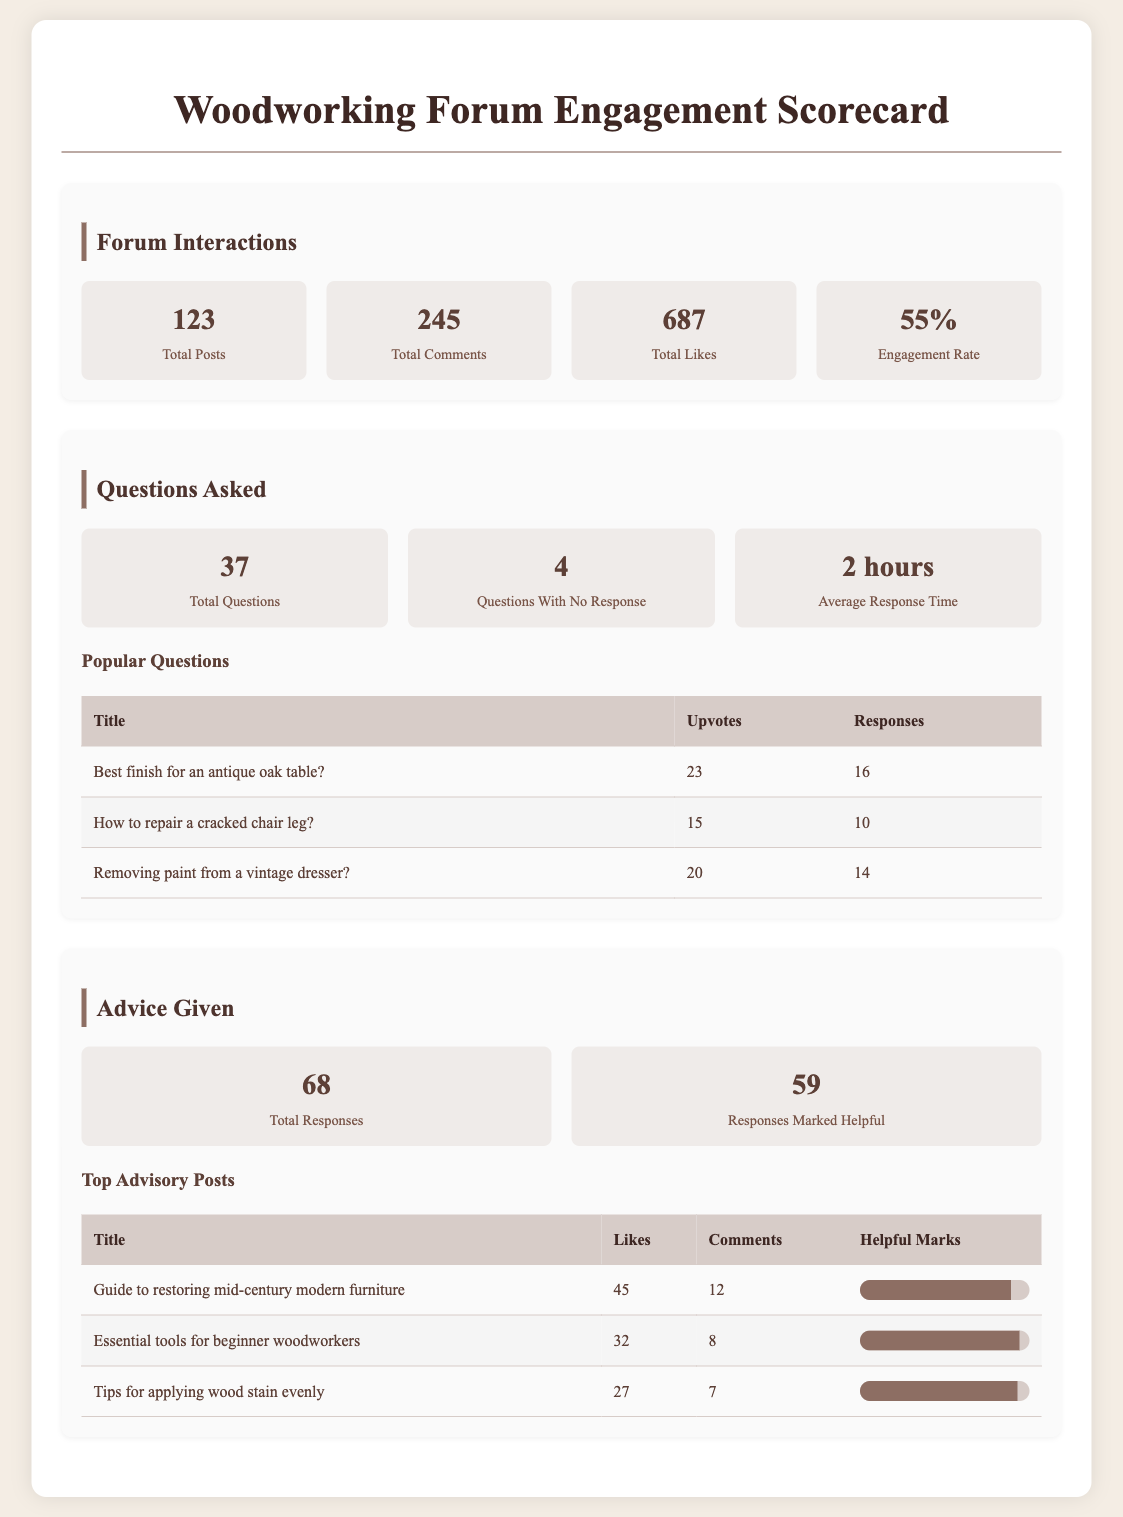What is the total number of posts? The total number of posts is mentioned under Forum Interactions, which is 123.
Answer: 123 How many comments were made in total? The total number of comments is indicated in the Forum Interactions section, which is 245.
Answer: 245 What is the engagement rate? The engagement rate is provided in the Forum Interactions section, which states it to be 55%.
Answer: 55% What percentage of questions went unanswered? To find the unanswered questions percentage, we use the formula (Questions With No Response / Total Questions) * 100 = (4 / 37) * 100, which gives approximately 10.81%.
Answer: 10.81% What is the average response time for questions? The average response time is listed in the Questions Asked section, which is 2 hours.
Answer: 2 hours Which question received the most upvotes? The question with the highest upvotes is "Best finish for an antique oak table?" with 23 upvotes.
Answer: Best finish for an antique oak table? How many responses were marked as helpful? The number of responses marked helpful can be found under Advice Given, which is 59.
Answer: 59 What guide has the highest helpful mark percentage? The guide with the highest helpful mark percentage is "Guide to restoring mid-century modern furniture," with 89% marked as helpful.
Answer: Guide to restoring mid-century modern furniture How many total questions were asked? The total number of questions is specified in the Questions Asked section, which is 37.
Answer: 37 